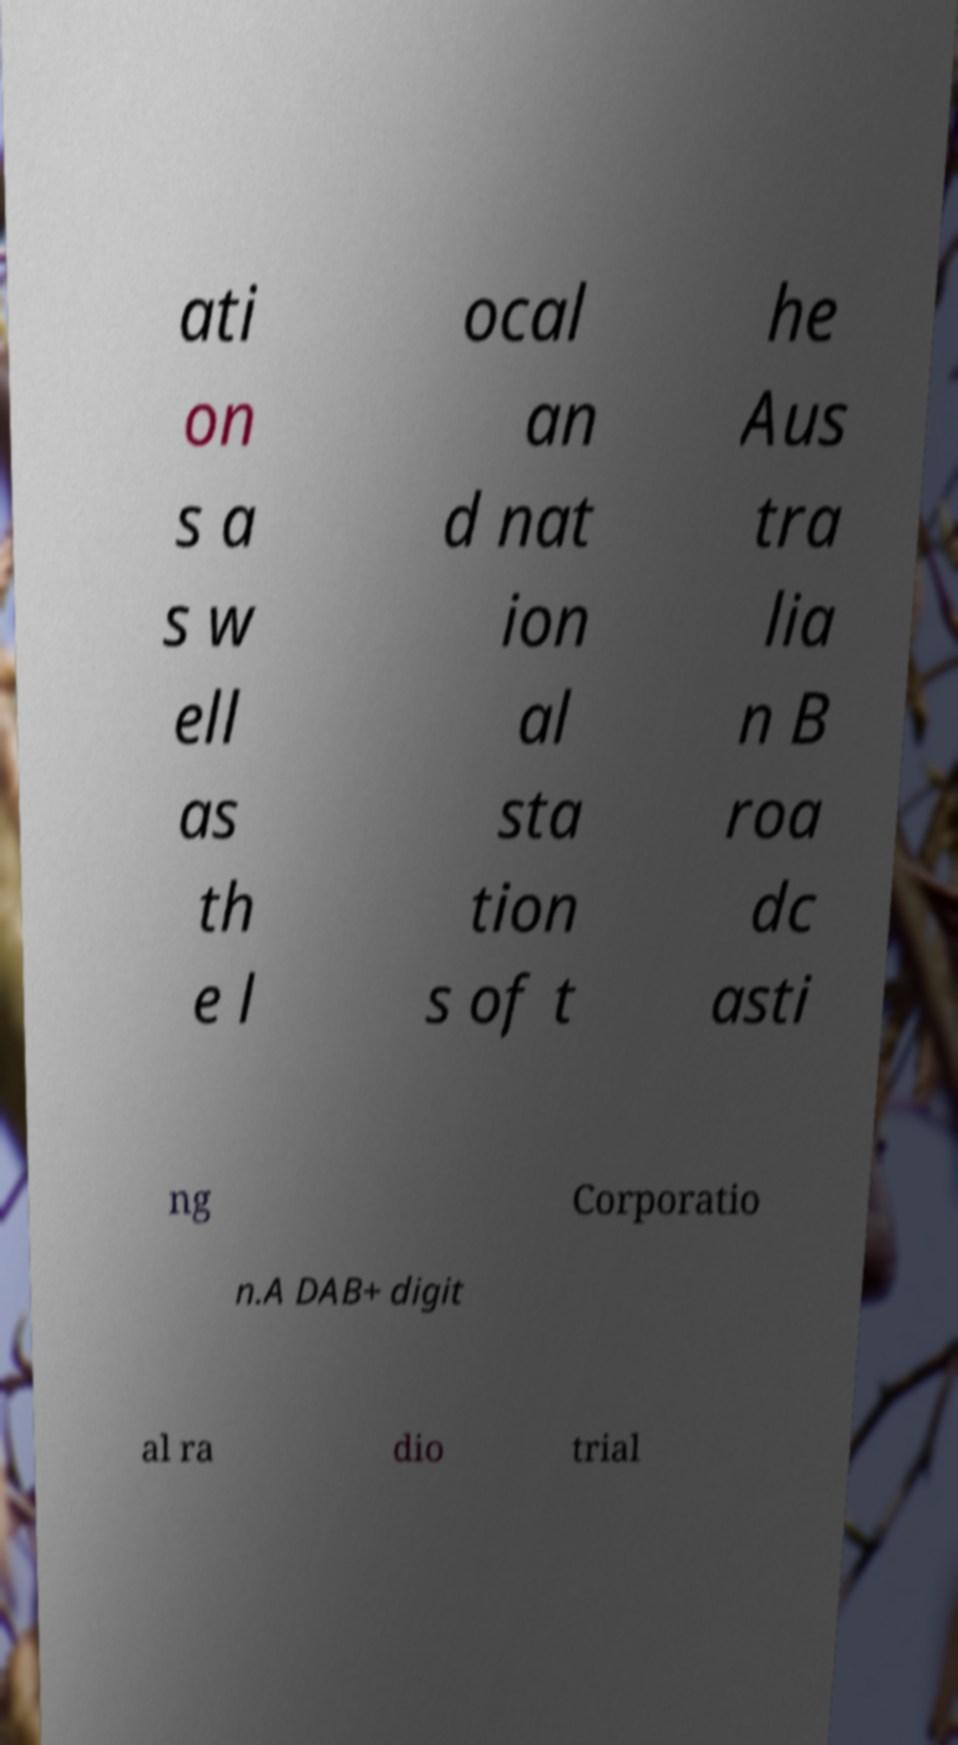Can you accurately transcribe the text from the provided image for me? ati on s a s w ell as th e l ocal an d nat ion al sta tion s of t he Aus tra lia n B roa dc asti ng Corporatio n.A DAB+ digit al ra dio trial 